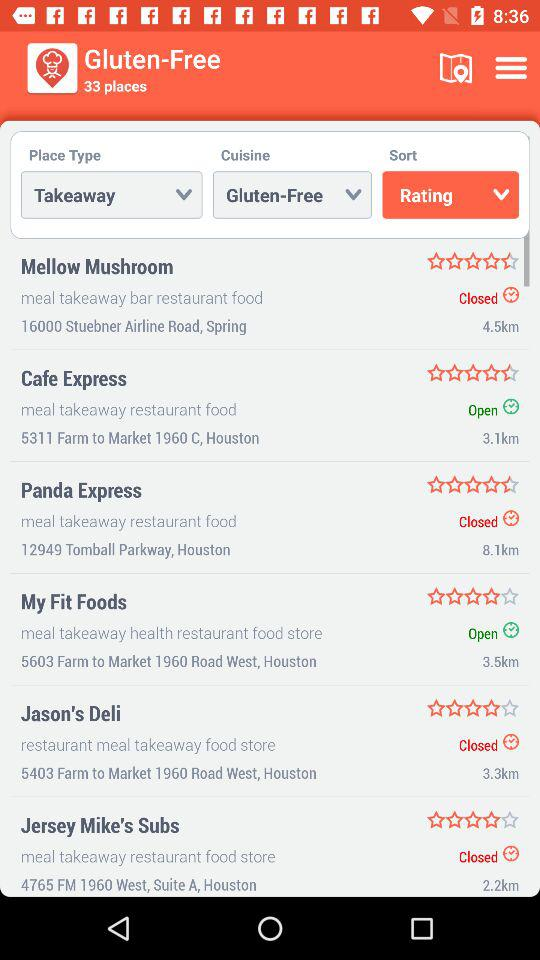In how many places is gluten-free food available? Gluten-free food is available in 33 places. 